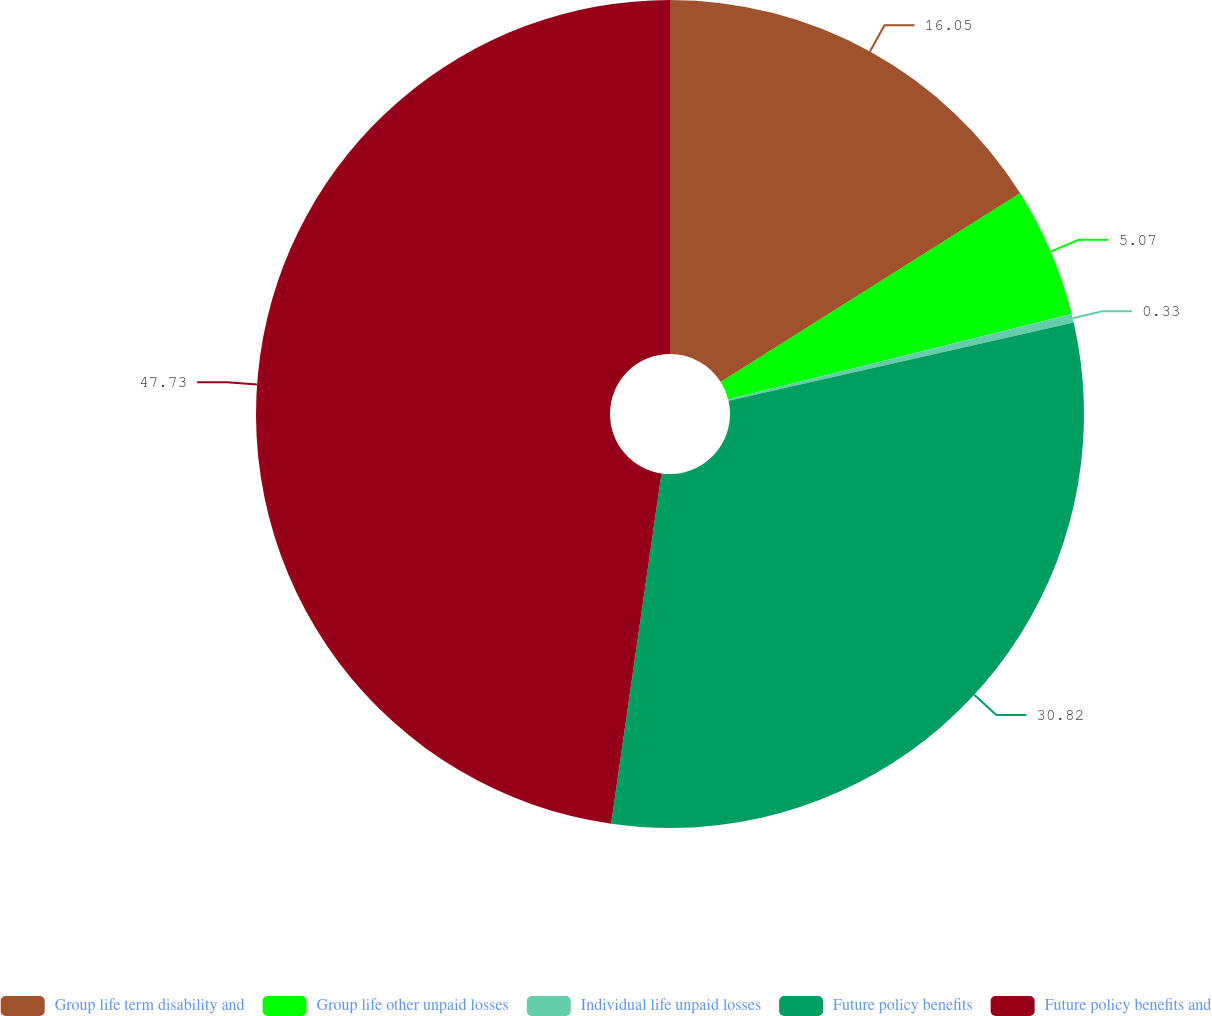Convert chart. <chart><loc_0><loc_0><loc_500><loc_500><pie_chart><fcel>Group life term disability and<fcel>Group life other unpaid losses<fcel>Individual life unpaid losses<fcel>Future policy benefits<fcel>Future policy benefits and<nl><fcel>16.05%<fcel>5.07%<fcel>0.33%<fcel>30.82%<fcel>47.73%<nl></chart> 